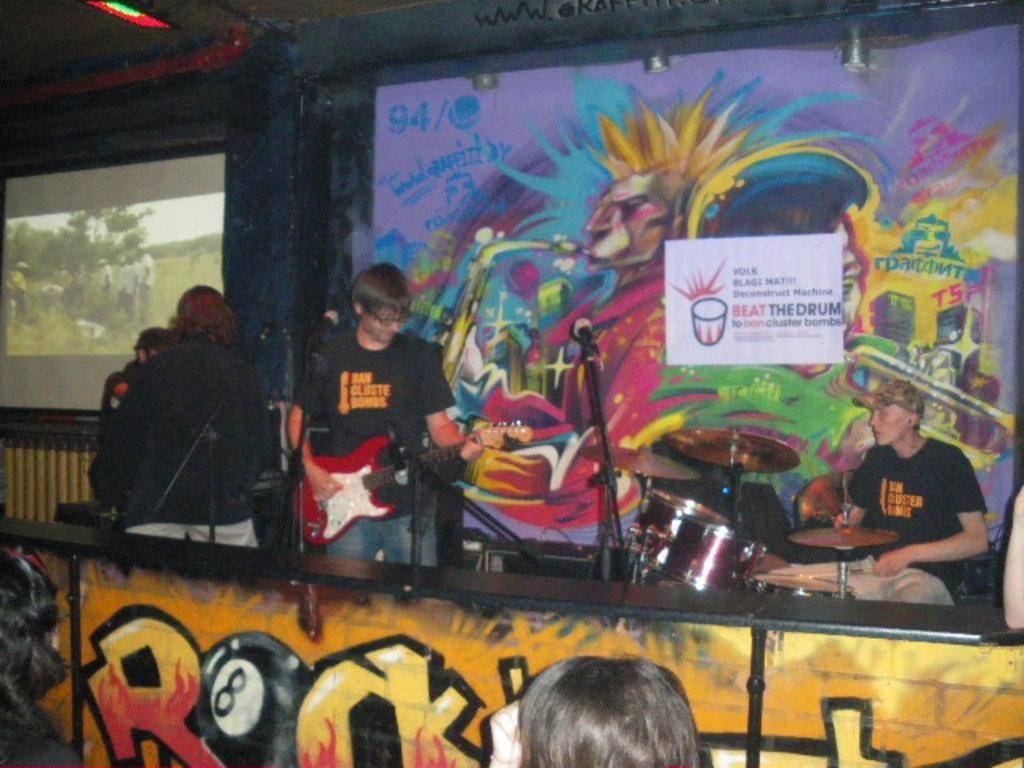Can you describe this image briefly? In this image there are people, musical instruments, mics, banner, board, lights, table, screen and objects. Among them two people are playing musical instruments. Graffiti is on the table and on the board.   